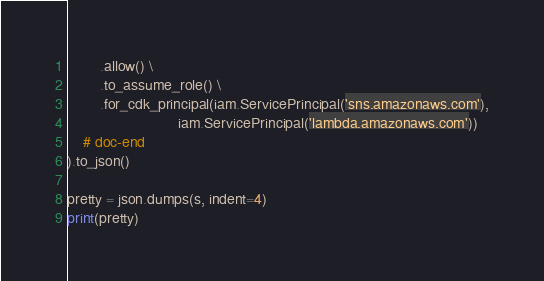Convert code to text. <code><loc_0><loc_0><loc_500><loc_500><_Python_>        .allow() \
        .to_assume_role() \
        .for_cdk_principal(iam.ServicePrincipal('sns.amazonaws.com'),
                           iam.ServicePrincipal('lambda.amazonaws.com'))
    # doc-end
).to_json()

pretty = json.dumps(s, indent=4)
print(pretty)
</code> 